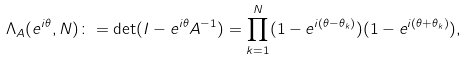Convert formula to latex. <formula><loc_0><loc_0><loc_500><loc_500>\Lambda _ { A } ( e ^ { i \theta } , N ) \colon = \det ( I - e ^ { i \theta } A ^ { - 1 } ) = \prod _ { k = 1 } ^ { N } ( 1 - e ^ { i ( \theta - \theta _ { k } ) } ) ( 1 - e ^ { i ( \theta + \theta _ { k } ) } ) ,</formula> 